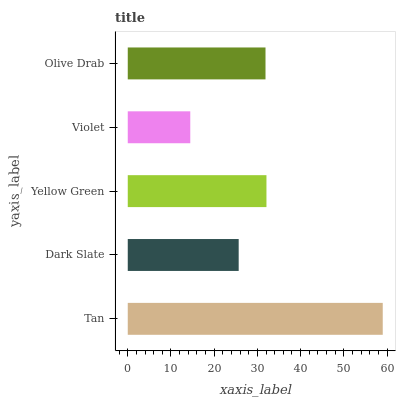Is Violet the minimum?
Answer yes or no. Yes. Is Tan the maximum?
Answer yes or no. Yes. Is Dark Slate the minimum?
Answer yes or no. No. Is Dark Slate the maximum?
Answer yes or no. No. Is Tan greater than Dark Slate?
Answer yes or no. Yes. Is Dark Slate less than Tan?
Answer yes or no. Yes. Is Dark Slate greater than Tan?
Answer yes or no. No. Is Tan less than Dark Slate?
Answer yes or no. No. Is Olive Drab the high median?
Answer yes or no. Yes. Is Olive Drab the low median?
Answer yes or no. Yes. Is Dark Slate the high median?
Answer yes or no. No. Is Violet the low median?
Answer yes or no. No. 